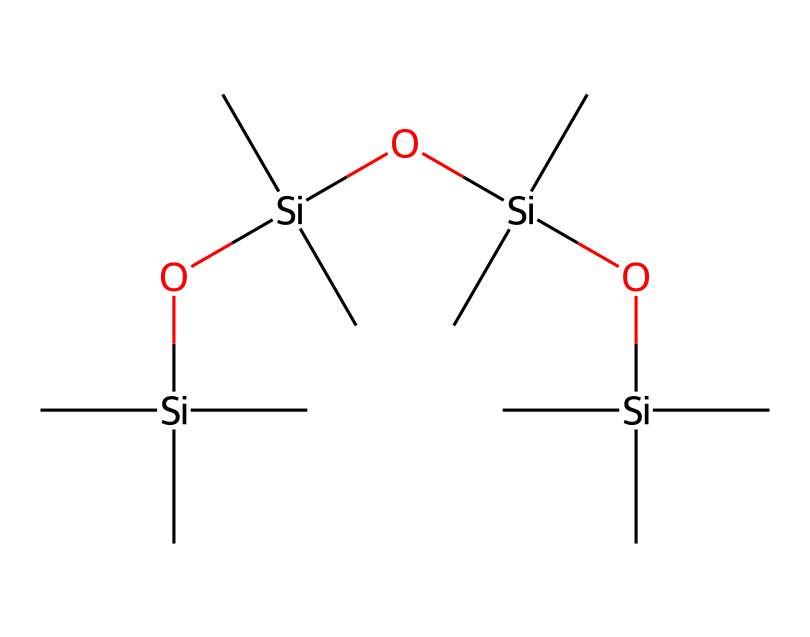how many silicon atoms are in this structure? By examining the SMILES representation, we can observe that there are four silicon atoms represented by the "[Si]" notation. Each silicon atom is bonded to oxygen and carbon atoms, which confirms their presence in the structure.
Answer: four how many hydroxyl groups are present in the compound? In the SMILES representation, hydroxyl groups are indicated by "O" followed by a silicon atom. Here, we find three occurrences of "O" as part of siloxane linkages directly bonded to the silicon atoms. Each of these structures corresponds to a hydroxyl group.
Answer: three what type of bonding is predominant in this chemical? The predominant bonding in this chemical is siloxane, characterized by the alternating silicon and oxygen atoms. This can be identified within the SMILES where multiple [Si] and associated O atoms are connected, revealing a siloxane polymer chain.
Answer: siloxane what is the main functional group in this compound? The main functional group in siloxane-based compounds is the silanol (-Si-OH) group. This is determined by the presence of the hydroxyl groups attached to silicon atoms in the chemical structure, showing its functional characteristics as a preservative.
Answer: silanol how many carbon atoms are in this structure? The carbon atoms are represented by "C" in the SMILES notation, specifically appearing alongside each silicon atom. As we analyze the structure, we find that there are 12 carbon atoms connected to the silicon atoms through branching structures.
Answer: twelve describe the branching structure in this compound The branching structure is evident as each silicon atom has several carbon atoms (indicated by "(C)") attached to it. Each Si atom is surrounded by various carbon groups, leading to a branched polymeric design with several organic moieties attached to the siloxane backbone.
Answer: branched structure 